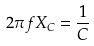<formula> <loc_0><loc_0><loc_500><loc_500>2 \pi f X _ { C } = \frac { 1 } { C }</formula> 